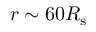Convert formula to latex. <formula><loc_0><loc_0><loc_500><loc_500>r \sim 6 0 R _ { s }</formula> 